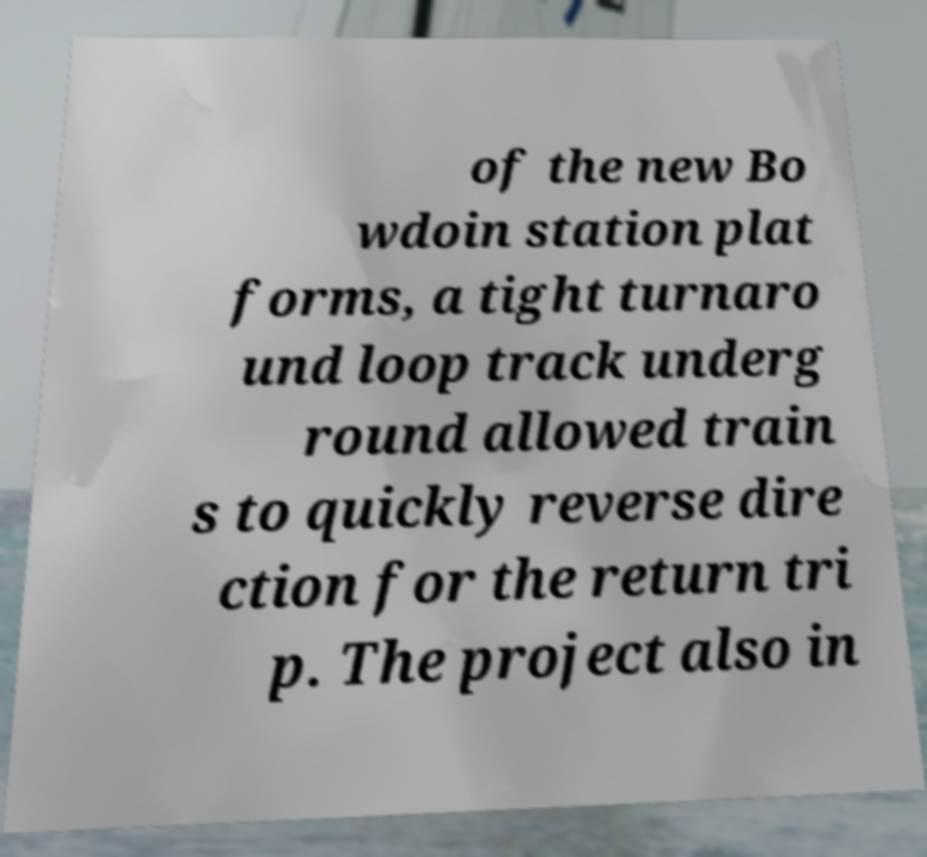Could you assist in decoding the text presented in this image and type it out clearly? of the new Bo wdoin station plat forms, a tight turnaro und loop track underg round allowed train s to quickly reverse dire ction for the return tri p. The project also in 